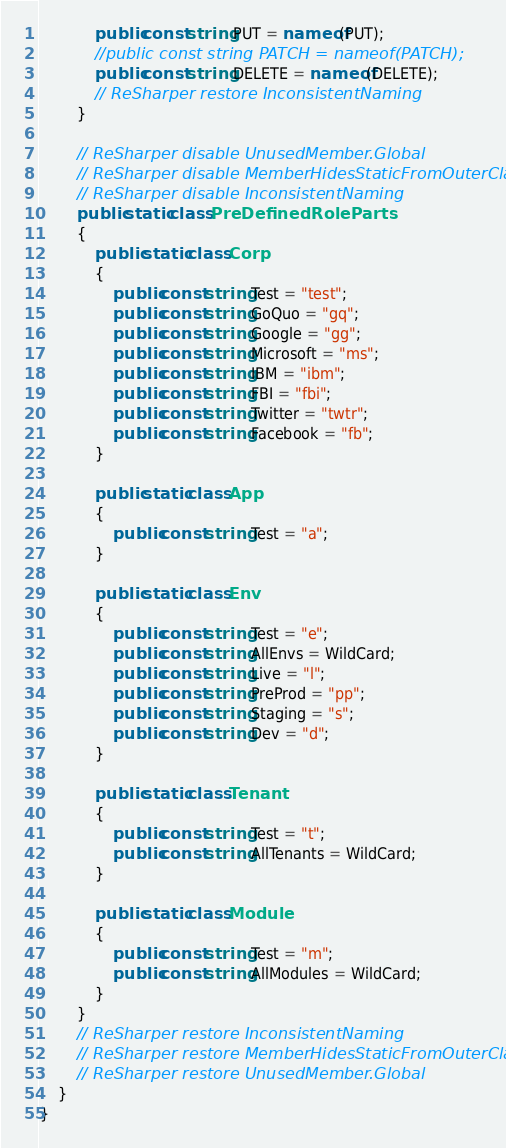<code> <loc_0><loc_0><loc_500><loc_500><_C#_>            public const string PUT = nameof(PUT);
            //public const string PATCH = nameof(PATCH);
            public const string DELETE = nameof(DELETE);
            // ReSharper restore InconsistentNaming
        }

        // ReSharper disable UnusedMember.Global
        // ReSharper disable MemberHidesStaticFromOuterClass
        // ReSharper disable InconsistentNaming
        public static class PreDefinedRoleParts
        {
            public static class Corp
            {
                public const string Test = "test";
                public const string GoQuo = "gq";
                public const string Google = "gg";
                public const string Microsoft = "ms";
                public const string IBM = "ibm";
                public const string FBI = "fbi";
                public const string Twitter = "twtr";
                public const string Facebook = "fb";
            }

            public static class App
            {
                public const string Test = "a";
            }

            public static class Env
            {
                public const string Test = "e";
                public const string AllEnvs = WildCard;
                public const string Live = "l";
                public const string PreProd = "pp";
                public const string Staging = "s";
                public const string Dev = "d";
            }

            public static class Tenant
            {
                public const string Test = "t";
                public const string AllTenants = WildCard;
            }

            public static class Module
            {
                public const string Test = "m";
                public const string AllModules = WildCard;
            }
        }
        // ReSharper restore InconsistentNaming
        // ReSharper restore MemberHidesStaticFromOuterClass
        // ReSharper restore UnusedMember.Global
    }
}</code> 